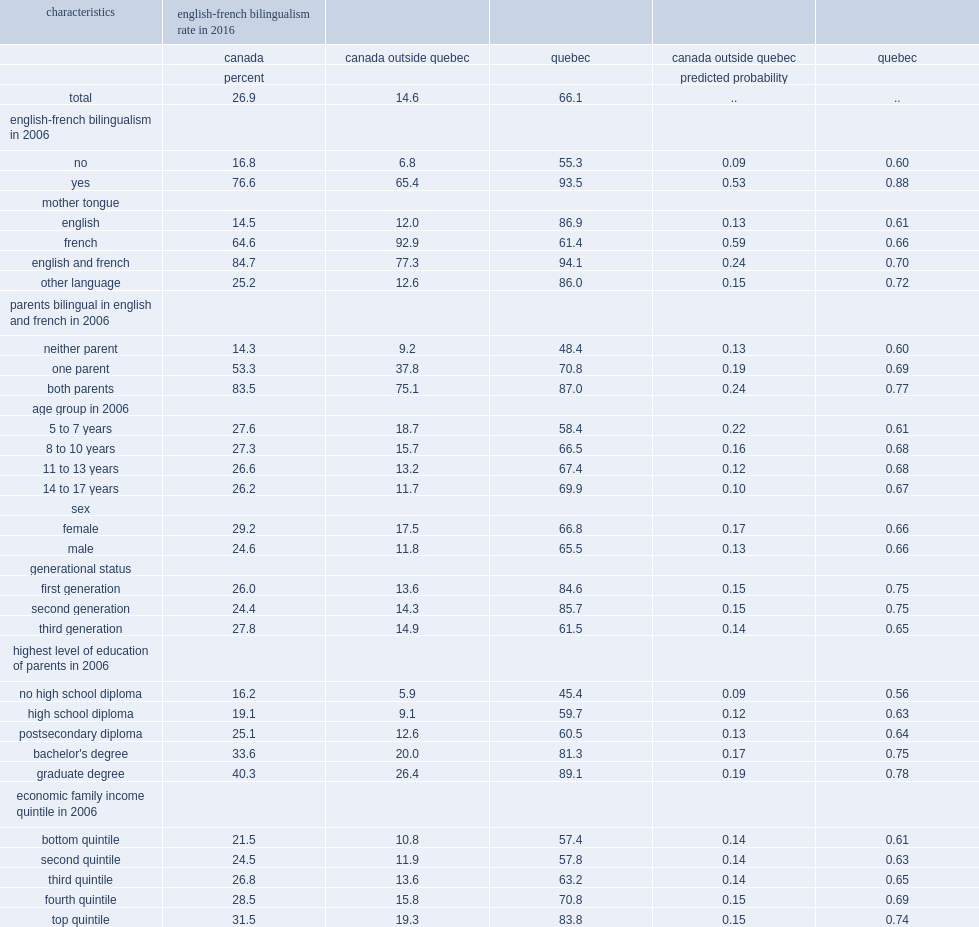Of the children and youth aged 5 to 17 in 2006 with french as a mother tongue in canada outside quebec, what the percent of people were bilingual in english and french in 2016? 93.5. What was the percent of their counterparts with english as a mother tongue? 12.0. What was the percent for those who had a mother tongue other than english or french? 12.6. In quebec, what was the percent of children and youth with english as a mother tongue were bilingual in english and french in 2016? 86.9. In quebec, what was the percent of their counterparts with french as a mother tongue? 61.4. In quebec, what was the percent of those with a mother tongue other than english or french? 86.0. When other factors were taken into account in the multivariate model, what was the predicted probability of being bilingual in english and french in 2016 for children and youth with french as a mother tongue? 0.66. When other factors were taken into account in the multivariate model, what was the predicted probability of being bilingual in english and french in 2016 was higher for children and youth with english as a mother tongue? 0.61. 